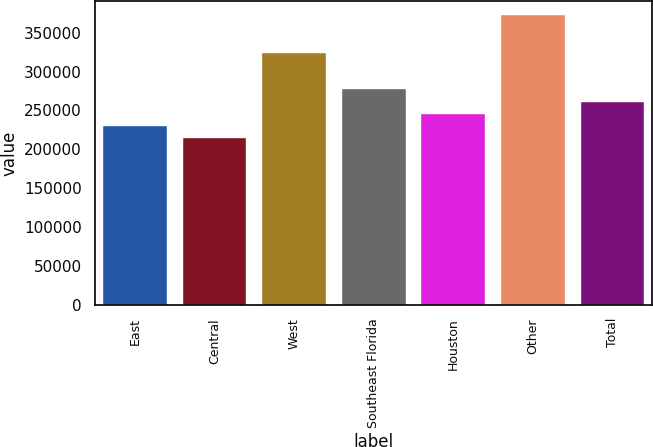Convert chart. <chart><loc_0><loc_0><loc_500><loc_500><bar_chart><fcel>East<fcel>Central<fcel>West<fcel>Southeast Florida<fcel>Houston<fcel>Other<fcel>Total<nl><fcel>229800<fcel>214000<fcel>324000<fcel>277200<fcel>245600<fcel>372000<fcel>261400<nl></chart> 